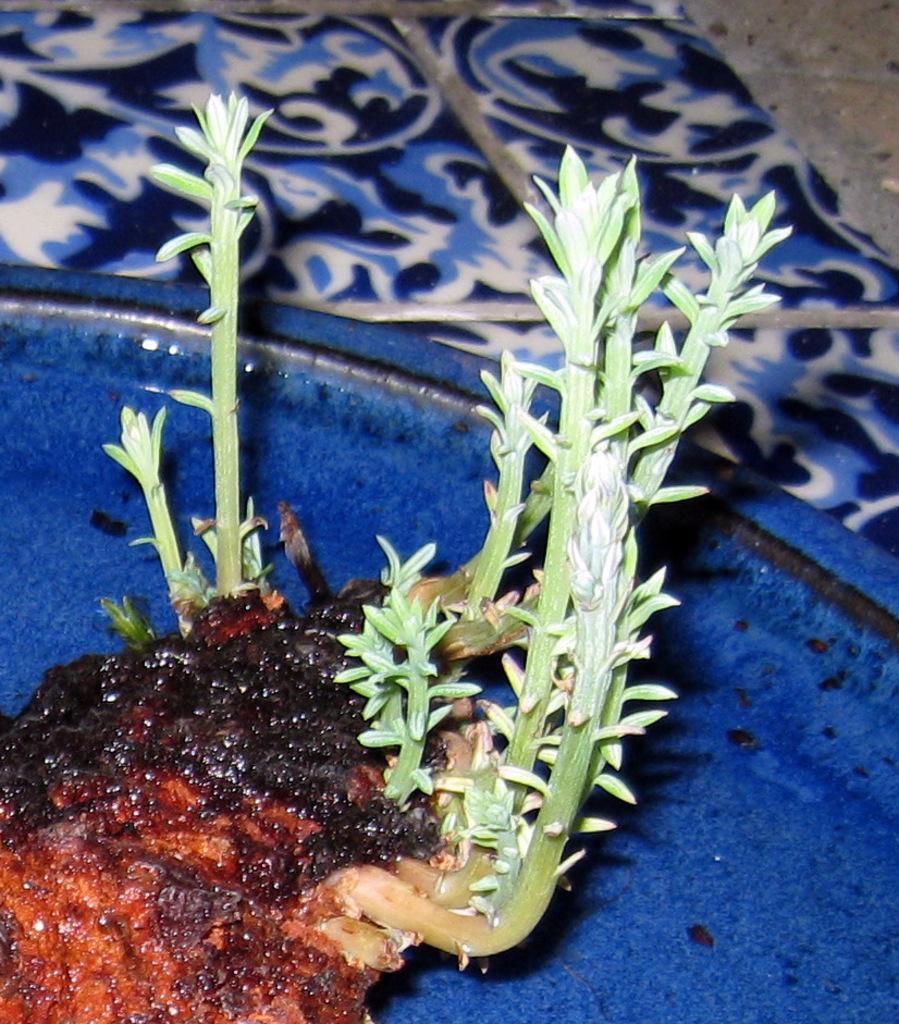Could you give a brief overview of what you see in this image? In this picture we can see plants in a blue tray and this tray is placed on a platform. 